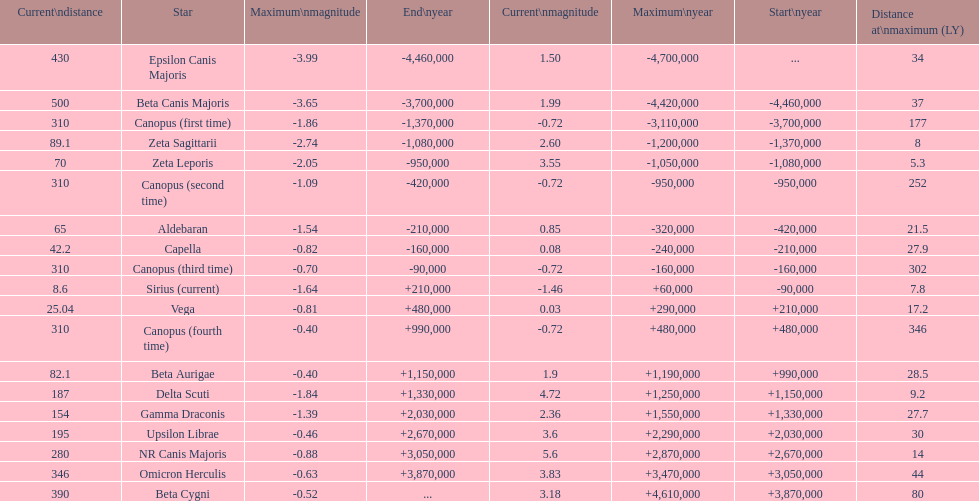How much farther (in ly) is epsilon canis majoris than zeta sagittarii? 26. 